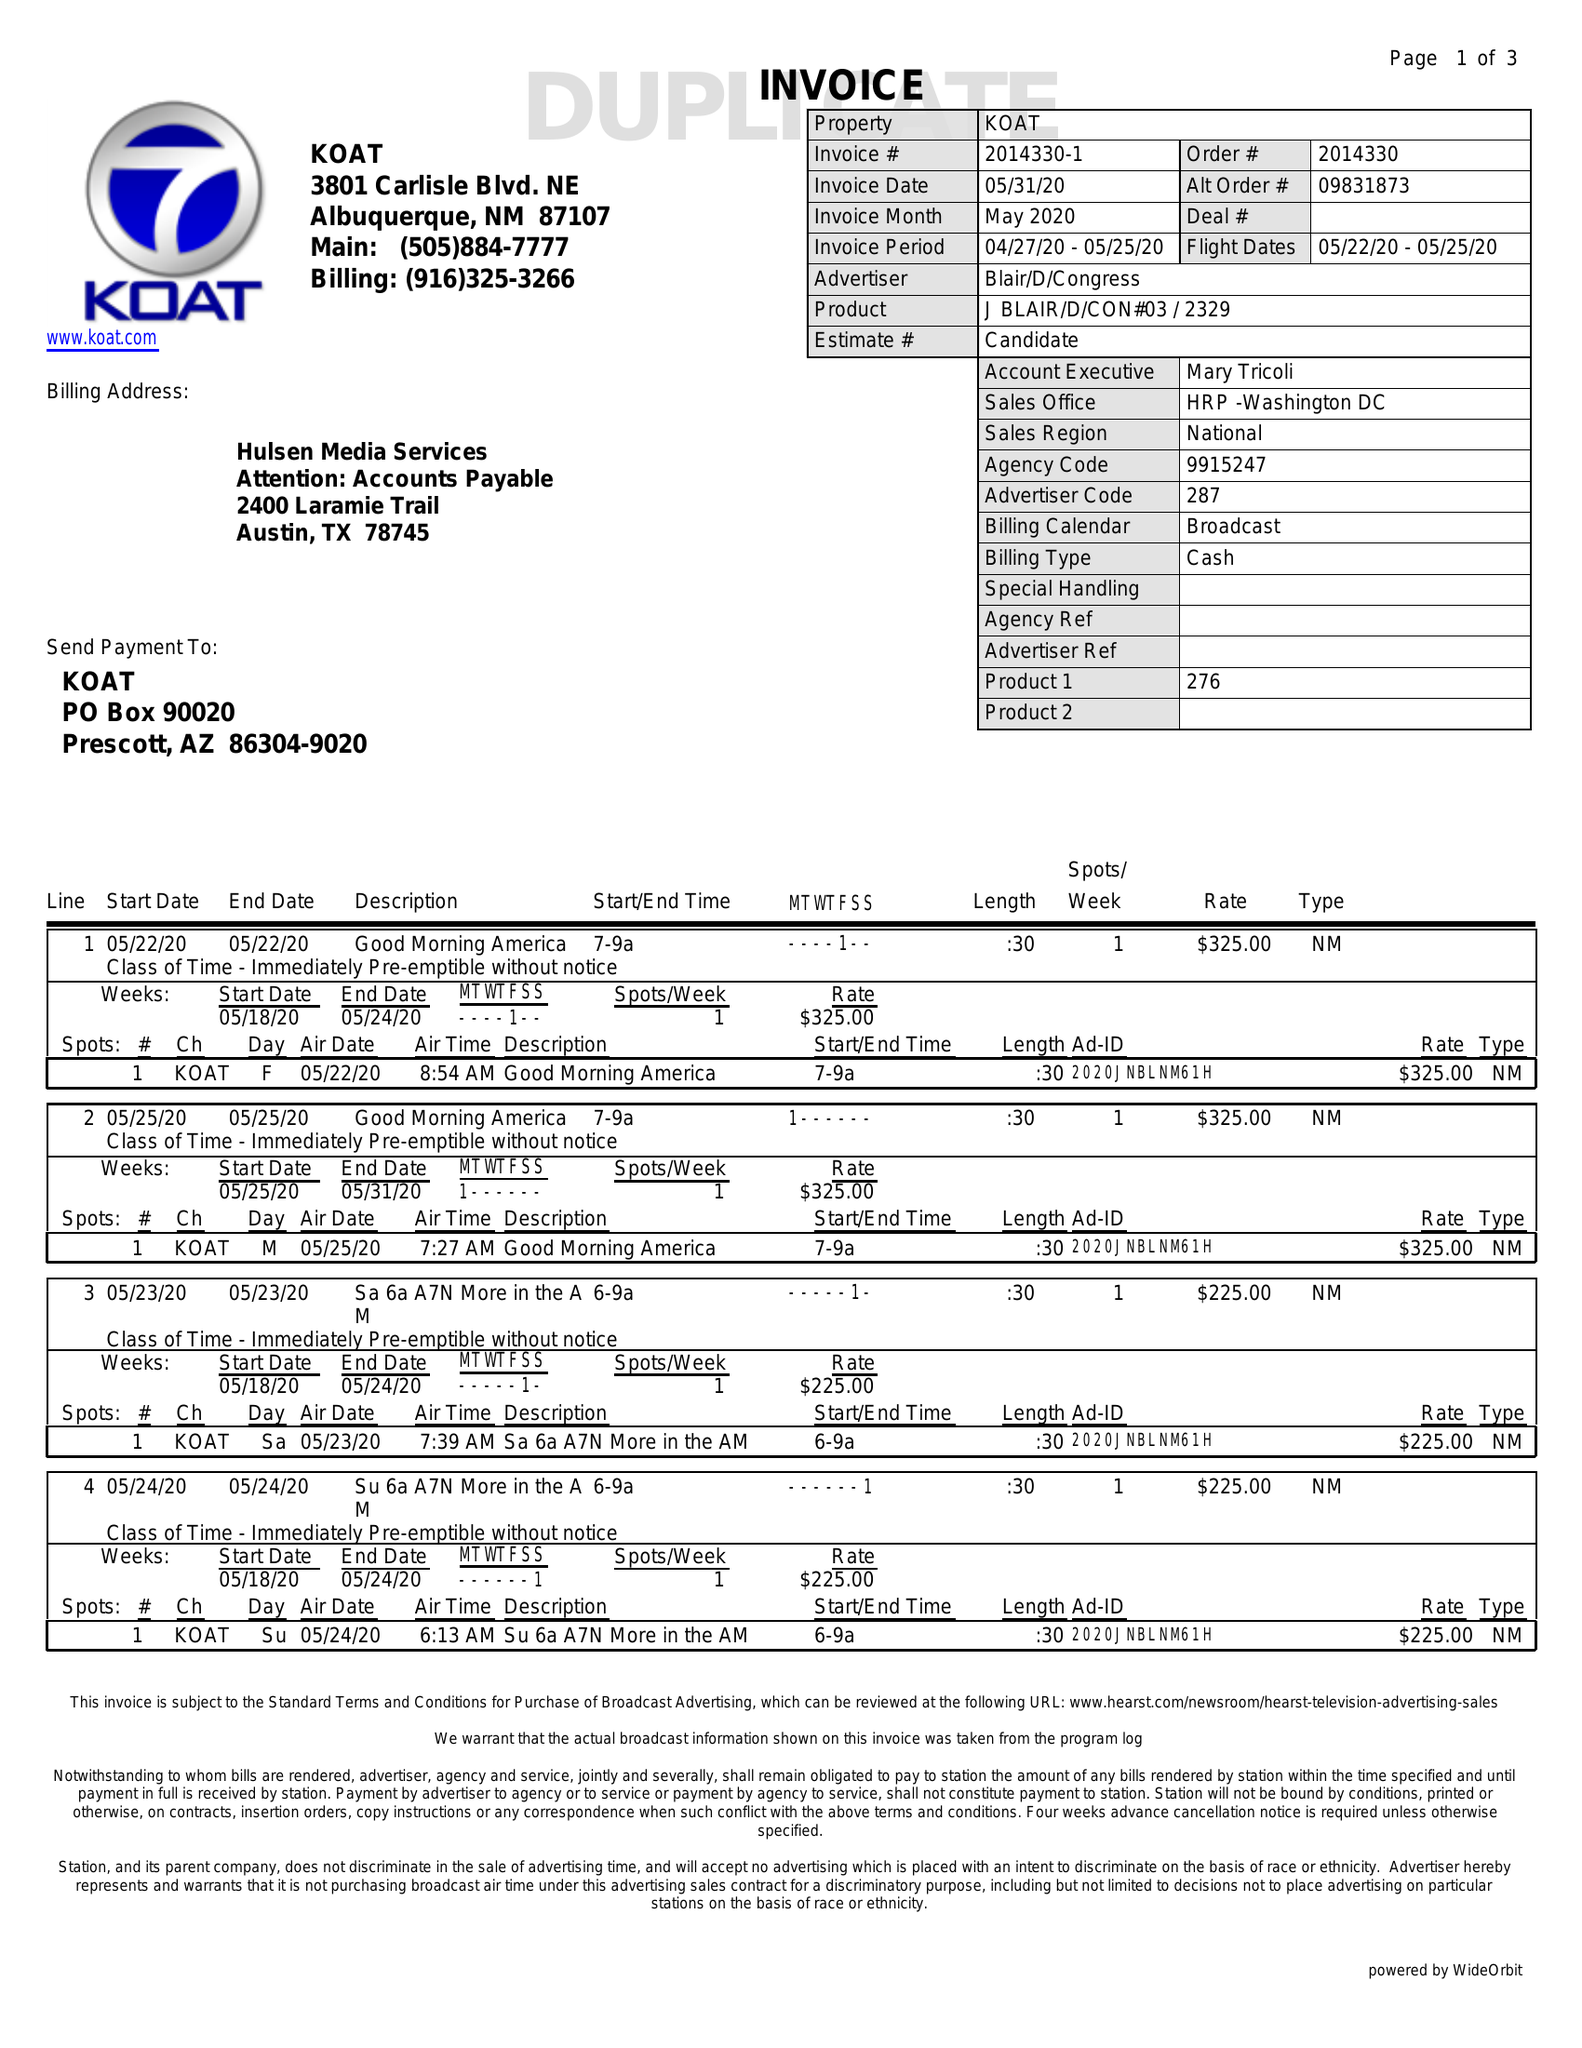What is the value for the contract_num?
Answer the question using a single word or phrase. 2014330 